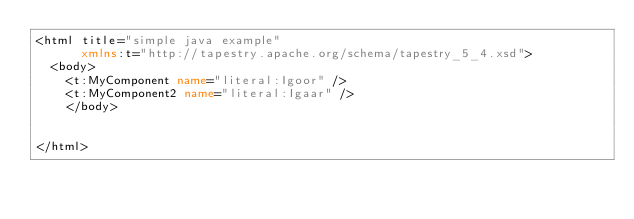<code> <loc_0><loc_0><loc_500><loc_500><_XML_><html title="simple java example"
      xmlns:t="http://tapestry.apache.org/schema/tapestry_5_4.xsd">
	<body>
		<t:MyComponent name="literal:Igoor" />
		<t:MyComponent2 name="literal:Igaar" />
    </body>
 

</html></code> 